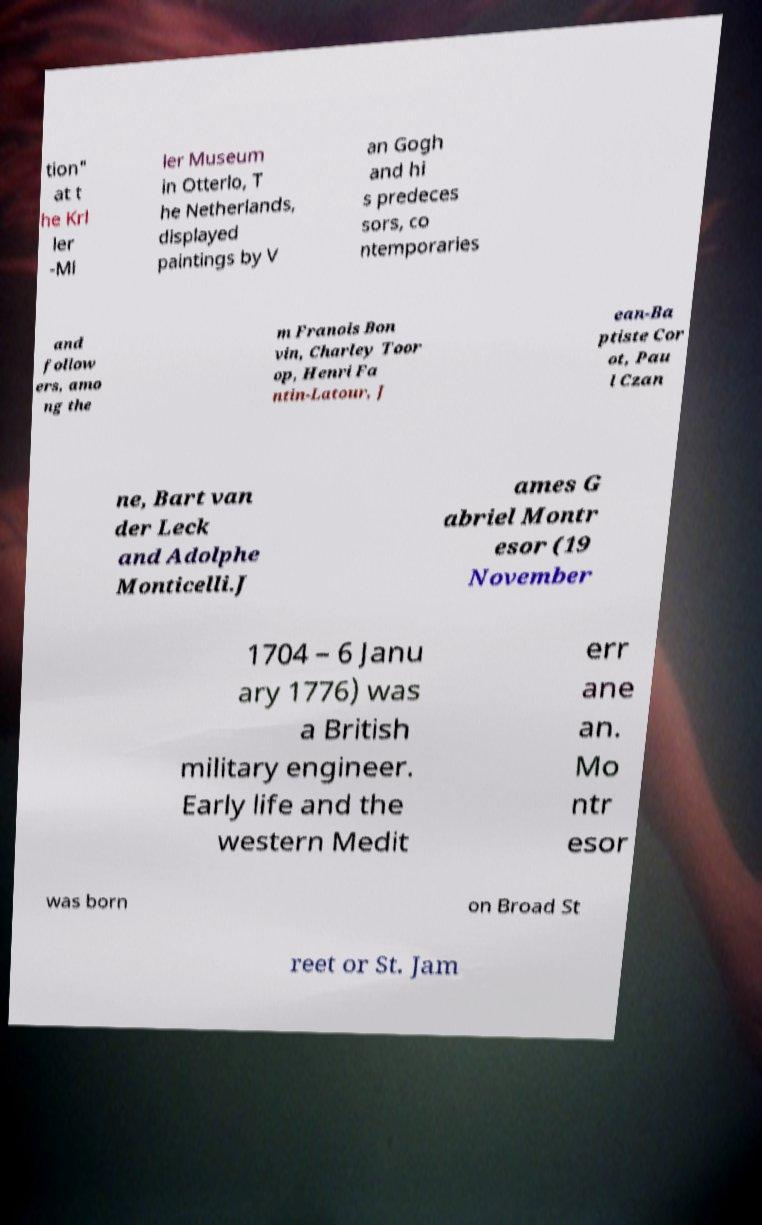There's text embedded in this image that I need extracted. Can you transcribe it verbatim? tion" at t he Krl ler -Ml ler Museum in Otterlo, T he Netherlands, displayed paintings by V an Gogh and hi s predeces sors, co ntemporaries and follow ers, amo ng the m Franois Bon vin, Charley Toor op, Henri Fa ntin-Latour, J ean-Ba ptiste Cor ot, Pau l Czan ne, Bart van der Leck and Adolphe Monticelli.J ames G abriel Montr esor (19 November 1704 – 6 Janu ary 1776) was a British military engineer. Early life and the western Medit err ane an. Mo ntr esor was born on Broad St reet or St. Jam 